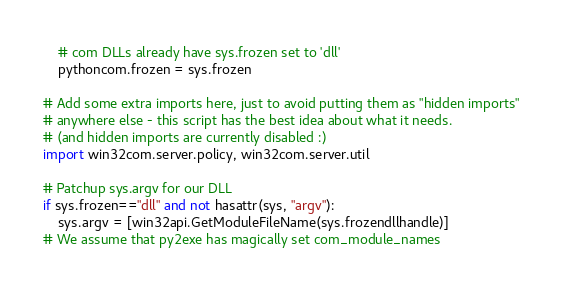Convert code to text. <code><loc_0><loc_0><loc_500><loc_500><_Python_>    # com DLLs already have sys.frozen set to 'dll'
    pythoncom.frozen = sys.frozen

# Add some extra imports here, just to avoid putting them as "hidden imports"
# anywhere else - this script has the best idea about what it needs.
# (and hidden imports are currently disabled :)
import win32com.server.policy, win32com.server.util

# Patchup sys.argv for our DLL
if sys.frozen=="dll" and not hasattr(sys, "argv"):
    sys.argv = [win32api.GetModuleFileName(sys.frozendllhandle)]
# We assume that py2exe has magically set com_module_names</code> 